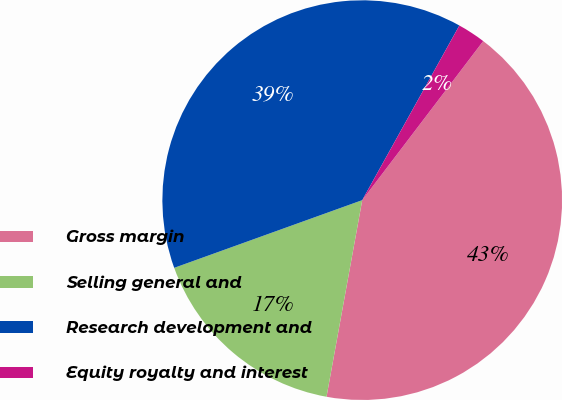<chart> <loc_0><loc_0><loc_500><loc_500><pie_chart><fcel>Gross margin<fcel>Selling general and<fcel>Research development and<fcel>Equity royalty and interest<nl><fcel>42.51%<fcel>16.64%<fcel>38.58%<fcel>2.27%<nl></chart> 